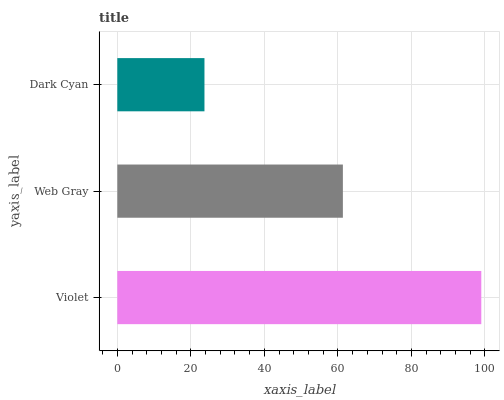Is Dark Cyan the minimum?
Answer yes or no. Yes. Is Violet the maximum?
Answer yes or no. Yes. Is Web Gray the minimum?
Answer yes or no. No. Is Web Gray the maximum?
Answer yes or no. No. Is Violet greater than Web Gray?
Answer yes or no. Yes. Is Web Gray less than Violet?
Answer yes or no. Yes. Is Web Gray greater than Violet?
Answer yes or no. No. Is Violet less than Web Gray?
Answer yes or no. No. Is Web Gray the high median?
Answer yes or no. Yes. Is Web Gray the low median?
Answer yes or no. Yes. Is Dark Cyan the high median?
Answer yes or no. No. Is Dark Cyan the low median?
Answer yes or no. No. 